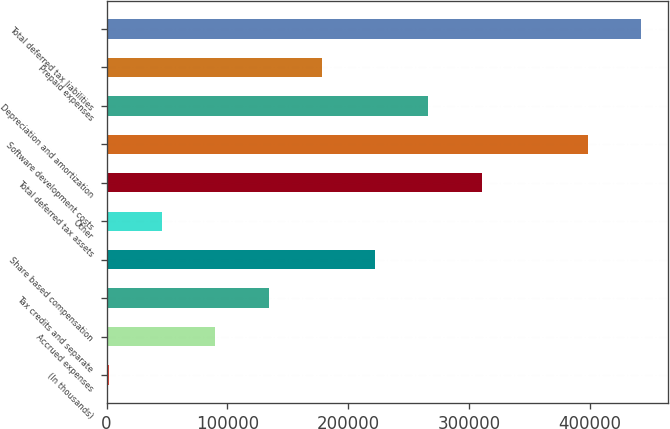Convert chart to OTSL. <chart><loc_0><loc_0><loc_500><loc_500><bar_chart><fcel>(In thousands)<fcel>Accrued expenses<fcel>Tax credits and separate<fcel>Share based compensation<fcel>Other<fcel>Total deferred tax assets<fcel>Software development costs<fcel>Depreciation and amortization<fcel>Prepaid expenses<fcel>Total deferred tax liabilities<nl><fcel>2016<fcel>90136.2<fcel>134196<fcel>222316<fcel>46076.1<fcel>310437<fcel>398557<fcel>266377<fcel>178256<fcel>442617<nl></chart> 